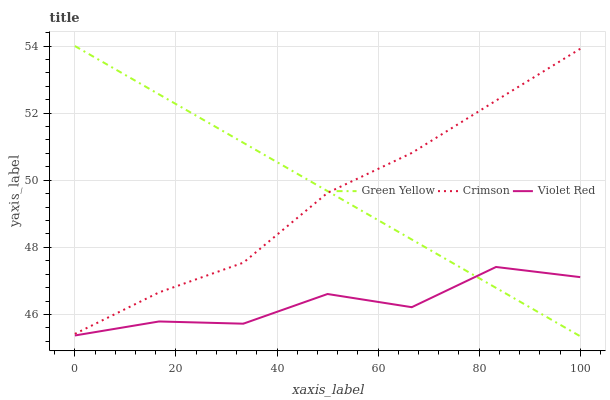Does Violet Red have the minimum area under the curve?
Answer yes or no. Yes. Does Green Yellow have the maximum area under the curve?
Answer yes or no. Yes. Does Green Yellow have the minimum area under the curve?
Answer yes or no. No. Does Violet Red have the maximum area under the curve?
Answer yes or no. No. Is Green Yellow the smoothest?
Answer yes or no. Yes. Is Violet Red the roughest?
Answer yes or no. Yes. Is Violet Red the smoothest?
Answer yes or no. No. Is Green Yellow the roughest?
Answer yes or no. No. Does Violet Red have the lowest value?
Answer yes or no. No. Does Green Yellow have the highest value?
Answer yes or no. Yes. Does Violet Red have the highest value?
Answer yes or no. No. Is Violet Red less than Crimson?
Answer yes or no. Yes. Is Crimson greater than Violet Red?
Answer yes or no. Yes. Does Green Yellow intersect Violet Red?
Answer yes or no. Yes. Is Green Yellow less than Violet Red?
Answer yes or no. No. Is Green Yellow greater than Violet Red?
Answer yes or no. No. Does Violet Red intersect Crimson?
Answer yes or no. No. 